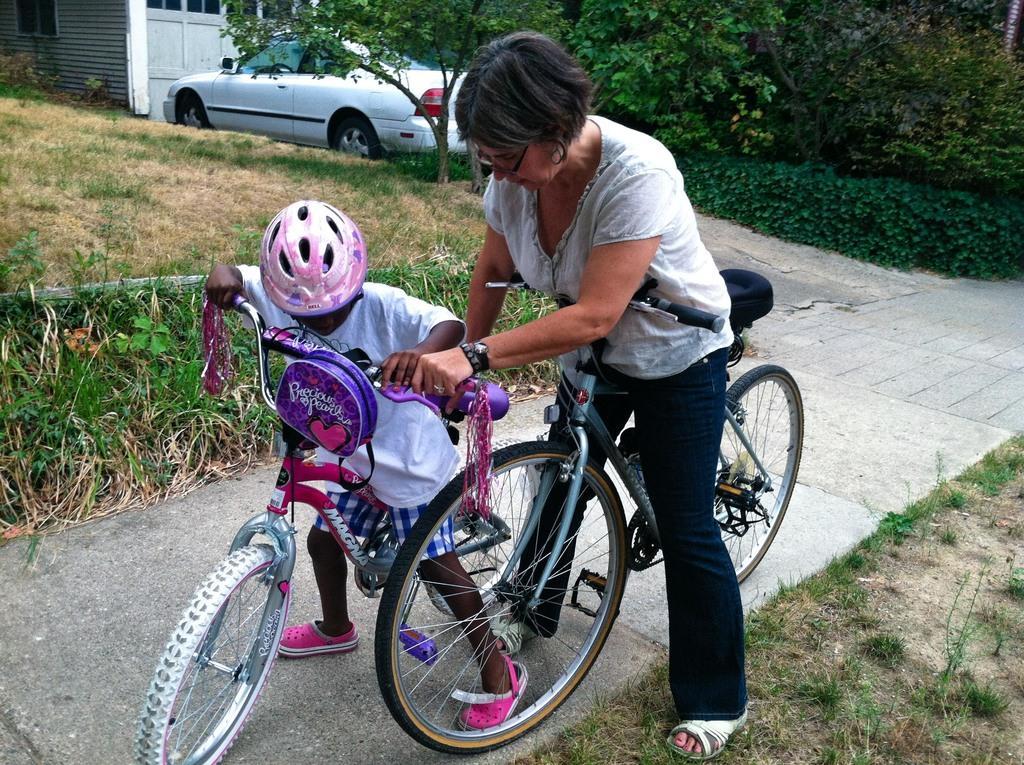How would you summarize this image in a sentence or two? In this image there is a woman and a kid standing on the road. They are holding bicycles in their hands. On the either sides of the road there are plants and grass on the ground. In the top left there is a house. There is a car parked in front of the house. In the background there are trees and hedges. 